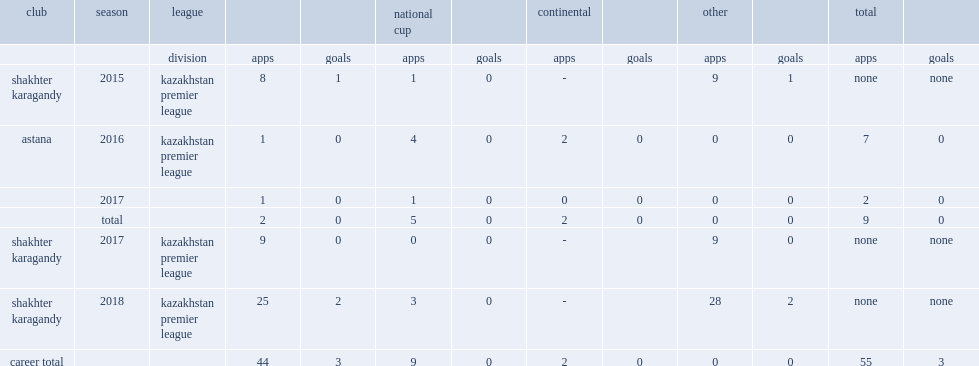In 2016, which club in kazakhstan premier league fc did najaryan move to? Astana. 